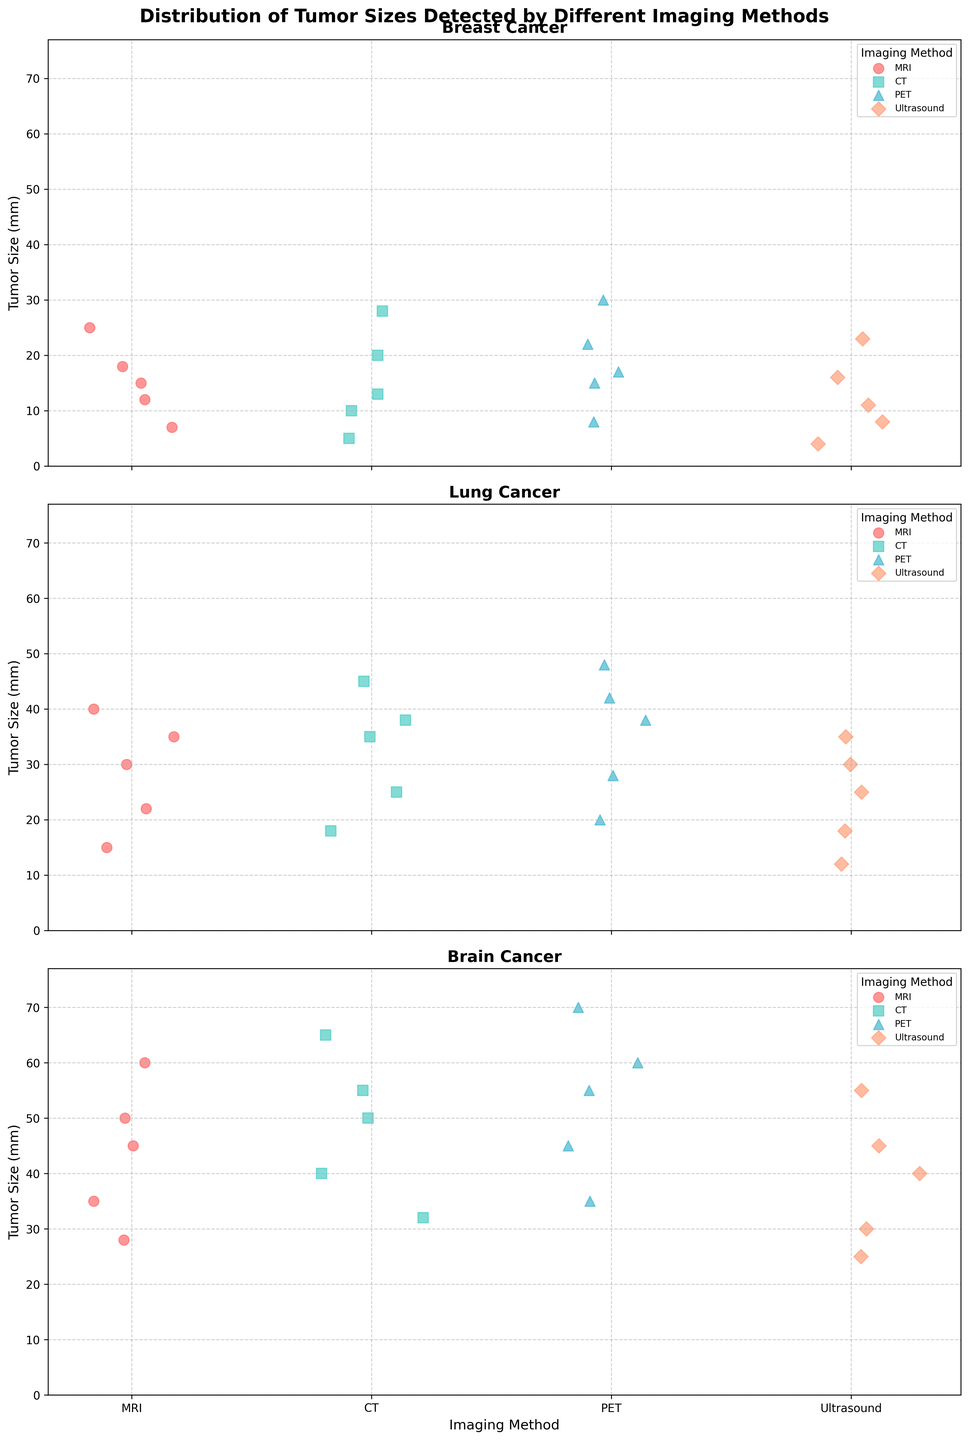Which imaging method detects the largest tumors in brain cancer? By observing the highest points in the subplot for brain cancer, it's evident that PET scans detect the largest tumors, with some detected tumor sizes reaching 70 mm.
Answer: PET How do the average tumor sizes detected by MRI and CT compare in lung cancer? Calculate the average tumor sizes for lung cancer using MRI and CT. For MRI, the average is (30+22+40+15+35)/5 = 142/5 = 28.4 mm. For CT, the average is (35+25+45+18+38)/5 = 161/5 = 32.2 mm. So, CT detects slightly larger tumors on average.
Answer: CT detects slightly larger tumors Which cancer type has the most consistent tumor sizes across different imaging methods? Look for the cancer type with the least spread in data points in the respective subplot. Breast cancer appears to have the most consistent tumor sizes, with points clustering around similar sizes regardless of imaging method.
Answer: Breast cancer Which imaging method shows the smallest tumor size in lung cancer? Identify the minimum data points in the lung cancer subplot. Ultrasound detects the smallest tumor, at 12 mm.
Answer: Ultrasound Do MRI and PET have notable overlaps in tumor size detection for brain cancer? Check if the data points for MRI and PET in the brain cancer subplot overlap significantly. Both methods detect a wide range of tumor sizes from around 28 mm to over 60 mm, indicating a notable overlap.
Answer: Yes, they have notable overlaps What's the median tumor size detected by Ultrasound in breast cancer? Sort the Ultrasound breast cancer tumor sizes (8, 16, 4, 23, 11) and find the middle value. Sorted values are (4, 8, 11, 16, 23), so the median is the middle number: 11 mm.
Answer: 11 mm Is there a significant difference between the maximum tumor sizes detected by MRI and CT in brain cancer? Compare the highest tumor sizes for MRI and CT in the brain cancer subplot. MRI max is 60 mm, while CT max is 65 mm, showing a slight difference.
Answer: No significant difference Which cancer type has the largest range of tumor sizes detected by PET? Check the range (difference between the largest and smallest tumor sizes) for all cancer types detected by PET. Brain cancer shows the largest range from 35 mm to 70 mm.
Answer: Brain cancer 